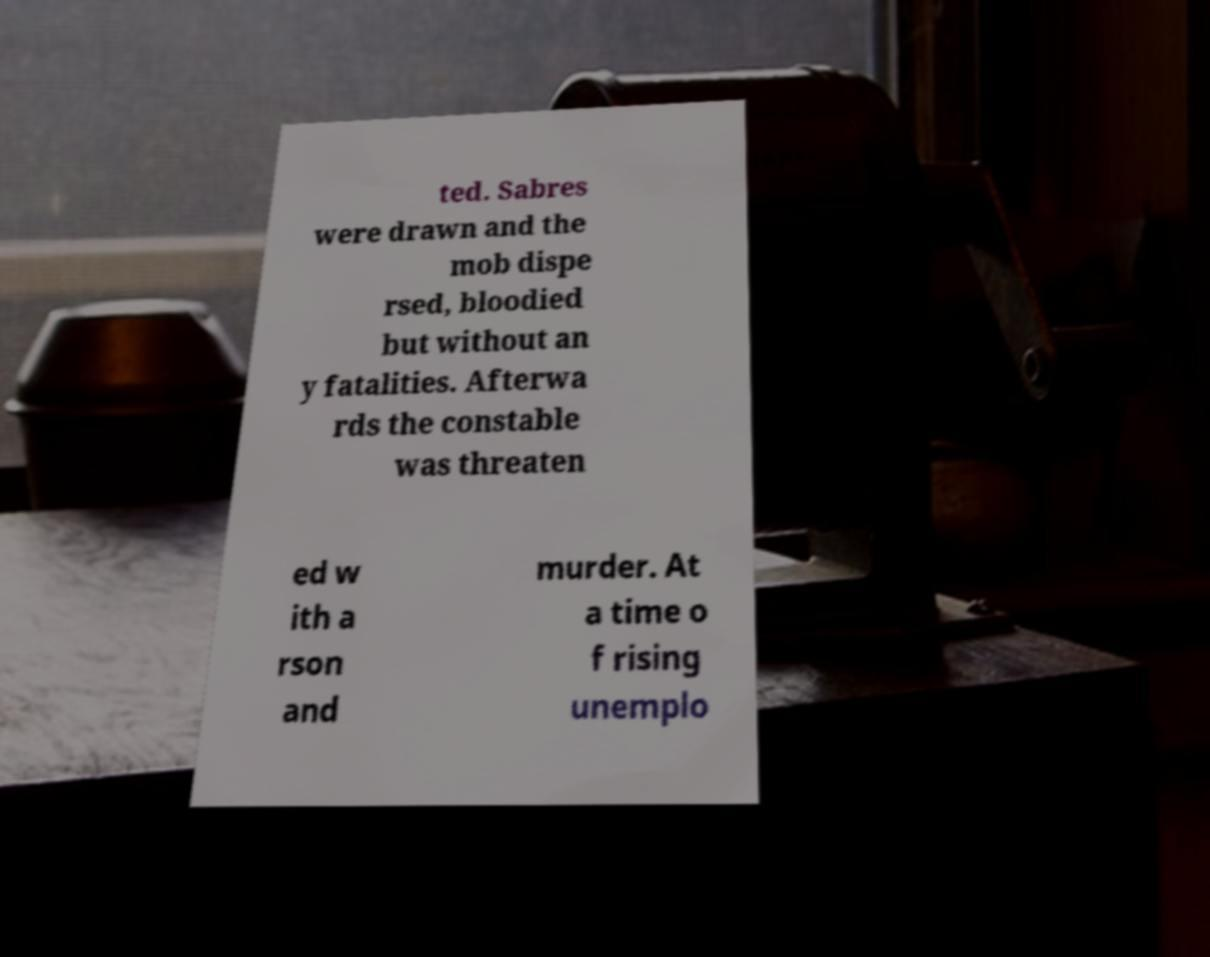Can you accurately transcribe the text from the provided image for me? ted. Sabres were drawn and the mob dispe rsed, bloodied but without an y fatalities. Afterwa rds the constable was threaten ed w ith a rson and murder. At a time o f rising unemplo 